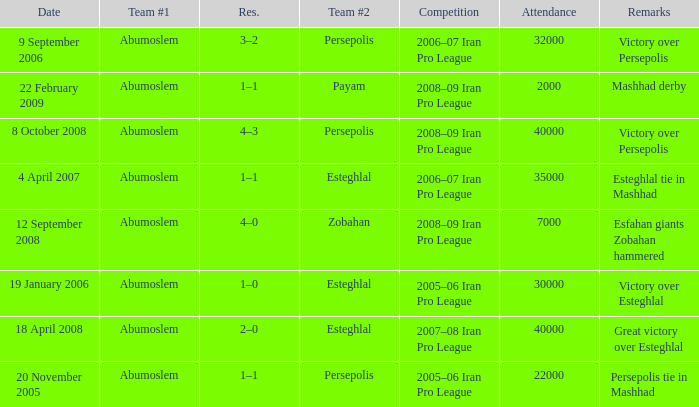Who was the leading team on 9th september 2006? Abumoslem. 